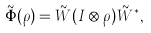<formula> <loc_0><loc_0><loc_500><loc_500>\tilde { \Phi } ( \rho ) = \tilde { W } ( I \otimes \rho ) \tilde { W } ^ { \ast } ,</formula> 